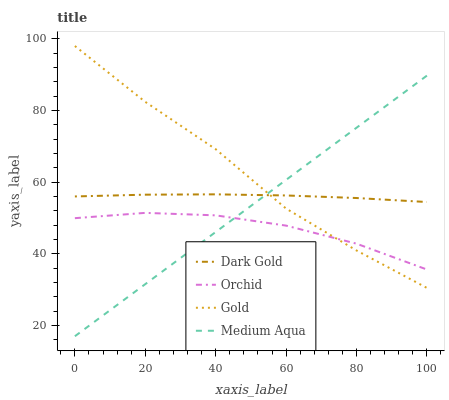Does Medium Aqua have the minimum area under the curve?
Answer yes or no. No. Does Medium Aqua have the maximum area under the curve?
Answer yes or no. No. Is Gold the smoothest?
Answer yes or no. No. Is Medium Aqua the roughest?
Answer yes or no. No. Does Gold have the lowest value?
Answer yes or no. No. Does Medium Aqua have the highest value?
Answer yes or no. No. Is Orchid less than Dark Gold?
Answer yes or no. Yes. Is Dark Gold greater than Orchid?
Answer yes or no. Yes. Does Orchid intersect Dark Gold?
Answer yes or no. No. 